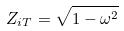<formula> <loc_0><loc_0><loc_500><loc_500>Z _ { i T } = \sqrt { 1 - \omega ^ { 2 } }</formula> 